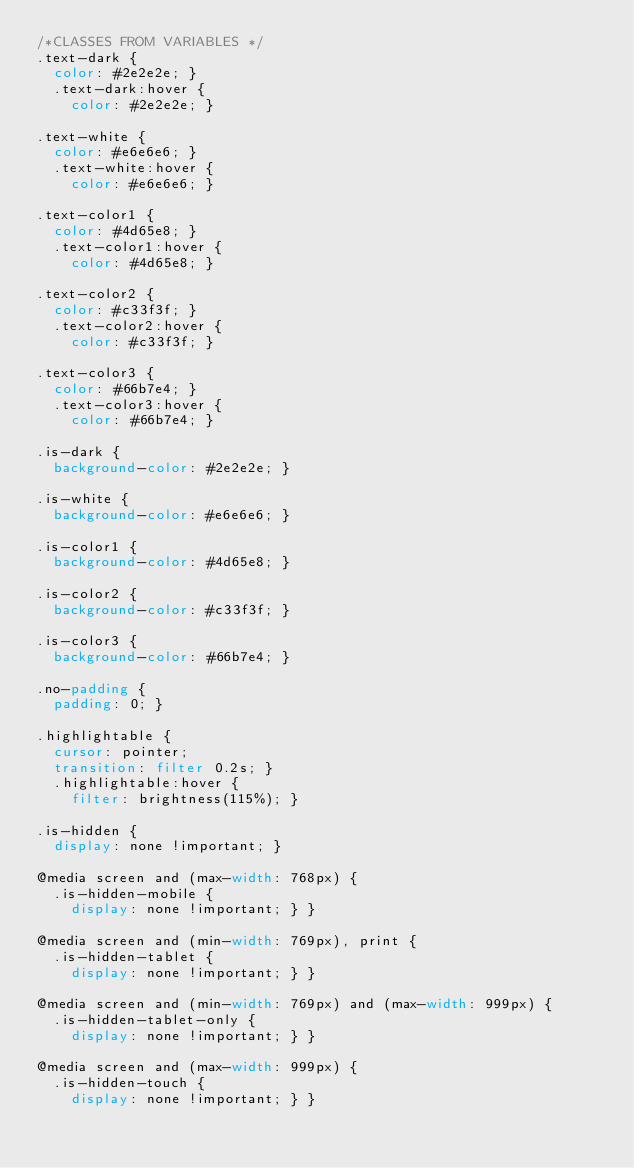Convert code to text. <code><loc_0><loc_0><loc_500><loc_500><_CSS_>/*CLASSES FROM VARIABLES */
.text-dark {
  color: #2e2e2e; }
  .text-dark:hover {
    color: #2e2e2e; }

.text-white {
  color: #e6e6e6; }
  .text-white:hover {
    color: #e6e6e6; }

.text-color1 {
  color: #4d65e8; }
  .text-color1:hover {
    color: #4d65e8; }

.text-color2 {
  color: #c33f3f; }
  .text-color2:hover {
    color: #c33f3f; }

.text-color3 {
  color: #66b7e4; }
  .text-color3:hover {
    color: #66b7e4; }

.is-dark {
  background-color: #2e2e2e; }

.is-white {
  background-color: #e6e6e6; }

.is-color1 {
  background-color: #4d65e8; }

.is-color2 {
  background-color: #c33f3f; }

.is-color3 {
  background-color: #66b7e4; }

.no-padding {
  padding: 0; }

.highlightable {
  cursor: pointer;
  transition: filter 0.2s; }
  .highlightable:hover {
    filter: brightness(115%); }

.is-hidden {
  display: none !important; }

@media screen and (max-width: 768px) {
  .is-hidden-mobile {
    display: none !important; } }

@media screen and (min-width: 769px), print {
  .is-hidden-tablet {
    display: none !important; } }

@media screen and (min-width: 769px) and (max-width: 999px) {
  .is-hidden-tablet-only {
    display: none !important; } }

@media screen and (max-width: 999px) {
  .is-hidden-touch {
    display: none !important; } }
</code> 